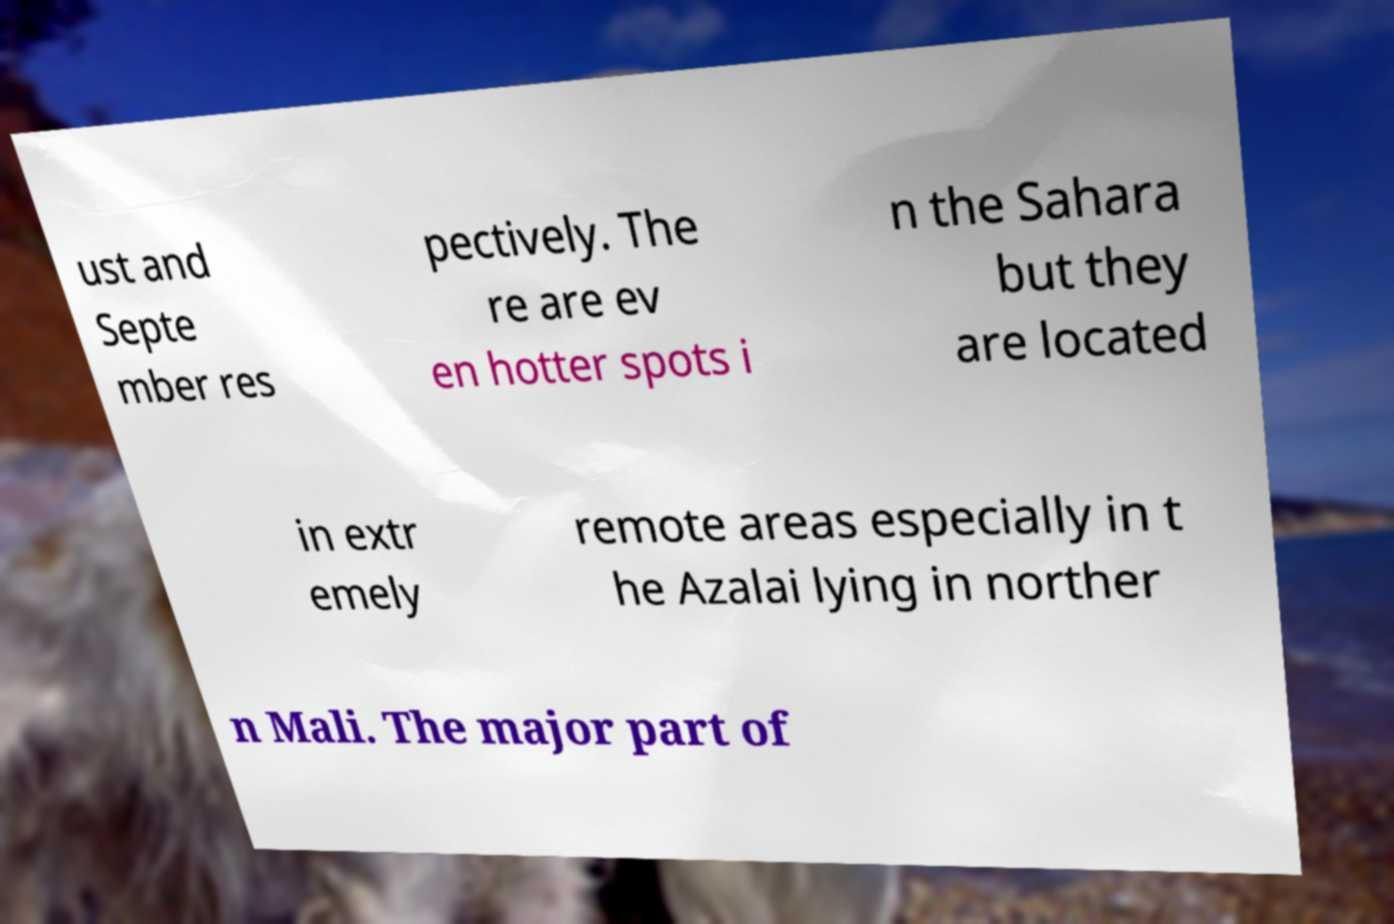Can you accurately transcribe the text from the provided image for me? ust and Septe mber res pectively. The re are ev en hotter spots i n the Sahara but they are located in extr emely remote areas especially in t he Azalai lying in norther n Mali. The major part of 